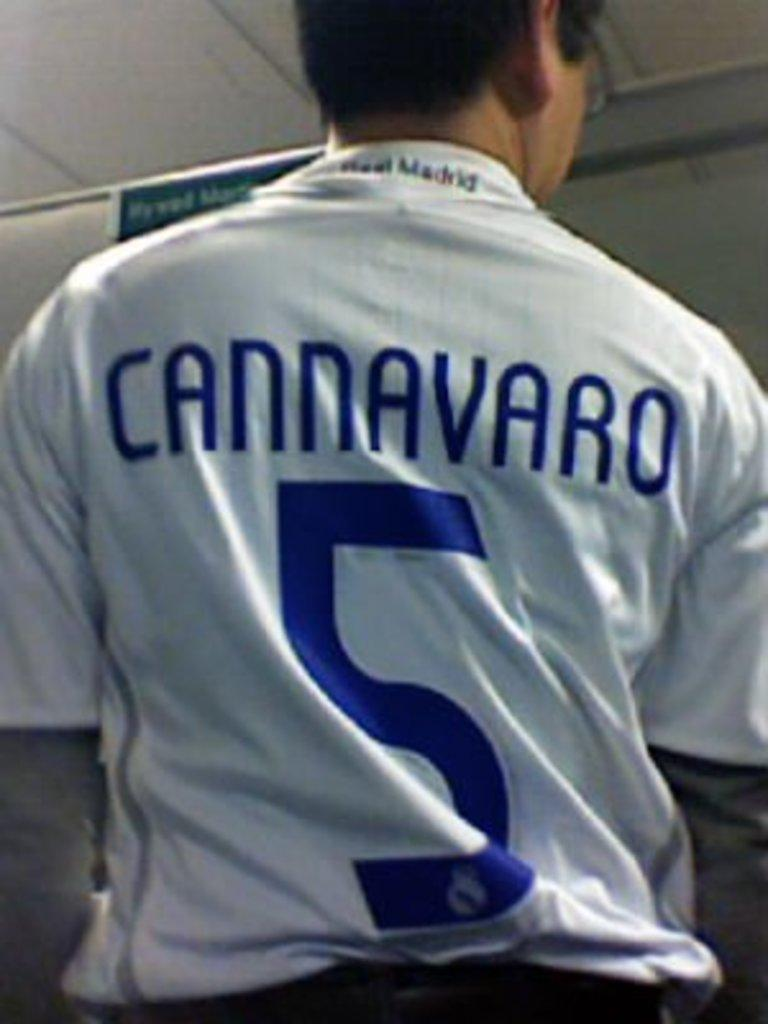Provide a one-sentence caption for the provided image. single man with a sport jersey that reads cannavaro. 